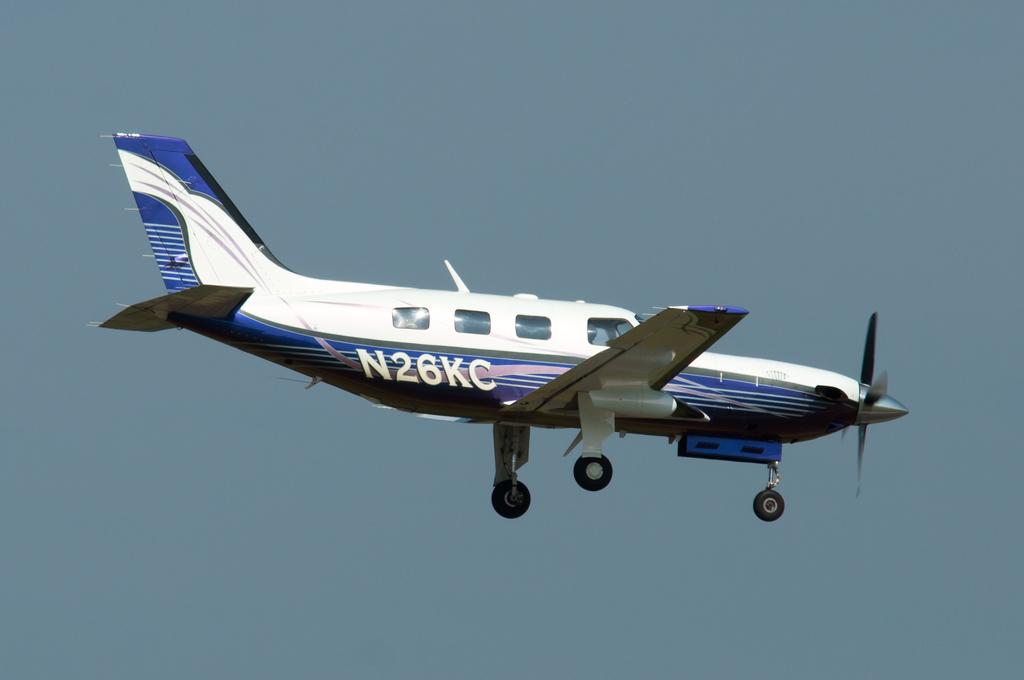What is the two digit numbers surrounded by letters?
Give a very brief answer. 26. What is the tag number written on the plane?
Ensure brevity in your answer.  N26kc. 